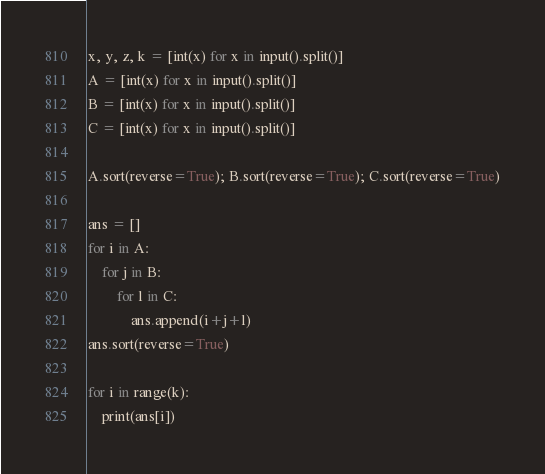Convert code to text. <code><loc_0><loc_0><loc_500><loc_500><_Python_>x, y, z, k = [int(x) for x in input().split()]
A = [int(x) for x in input().split()]
B = [int(x) for x in input().split()]
C = [int(x) for x in input().split()]

A.sort(reverse=True); B.sort(reverse=True); C.sort(reverse=True)

ans = []
for i in A:
    for j in B:
        for l in C:
            ans.append(i+j+l)
ans.sort(reverse=True)

for i in range(k):
    print(ans[i])
</code> 